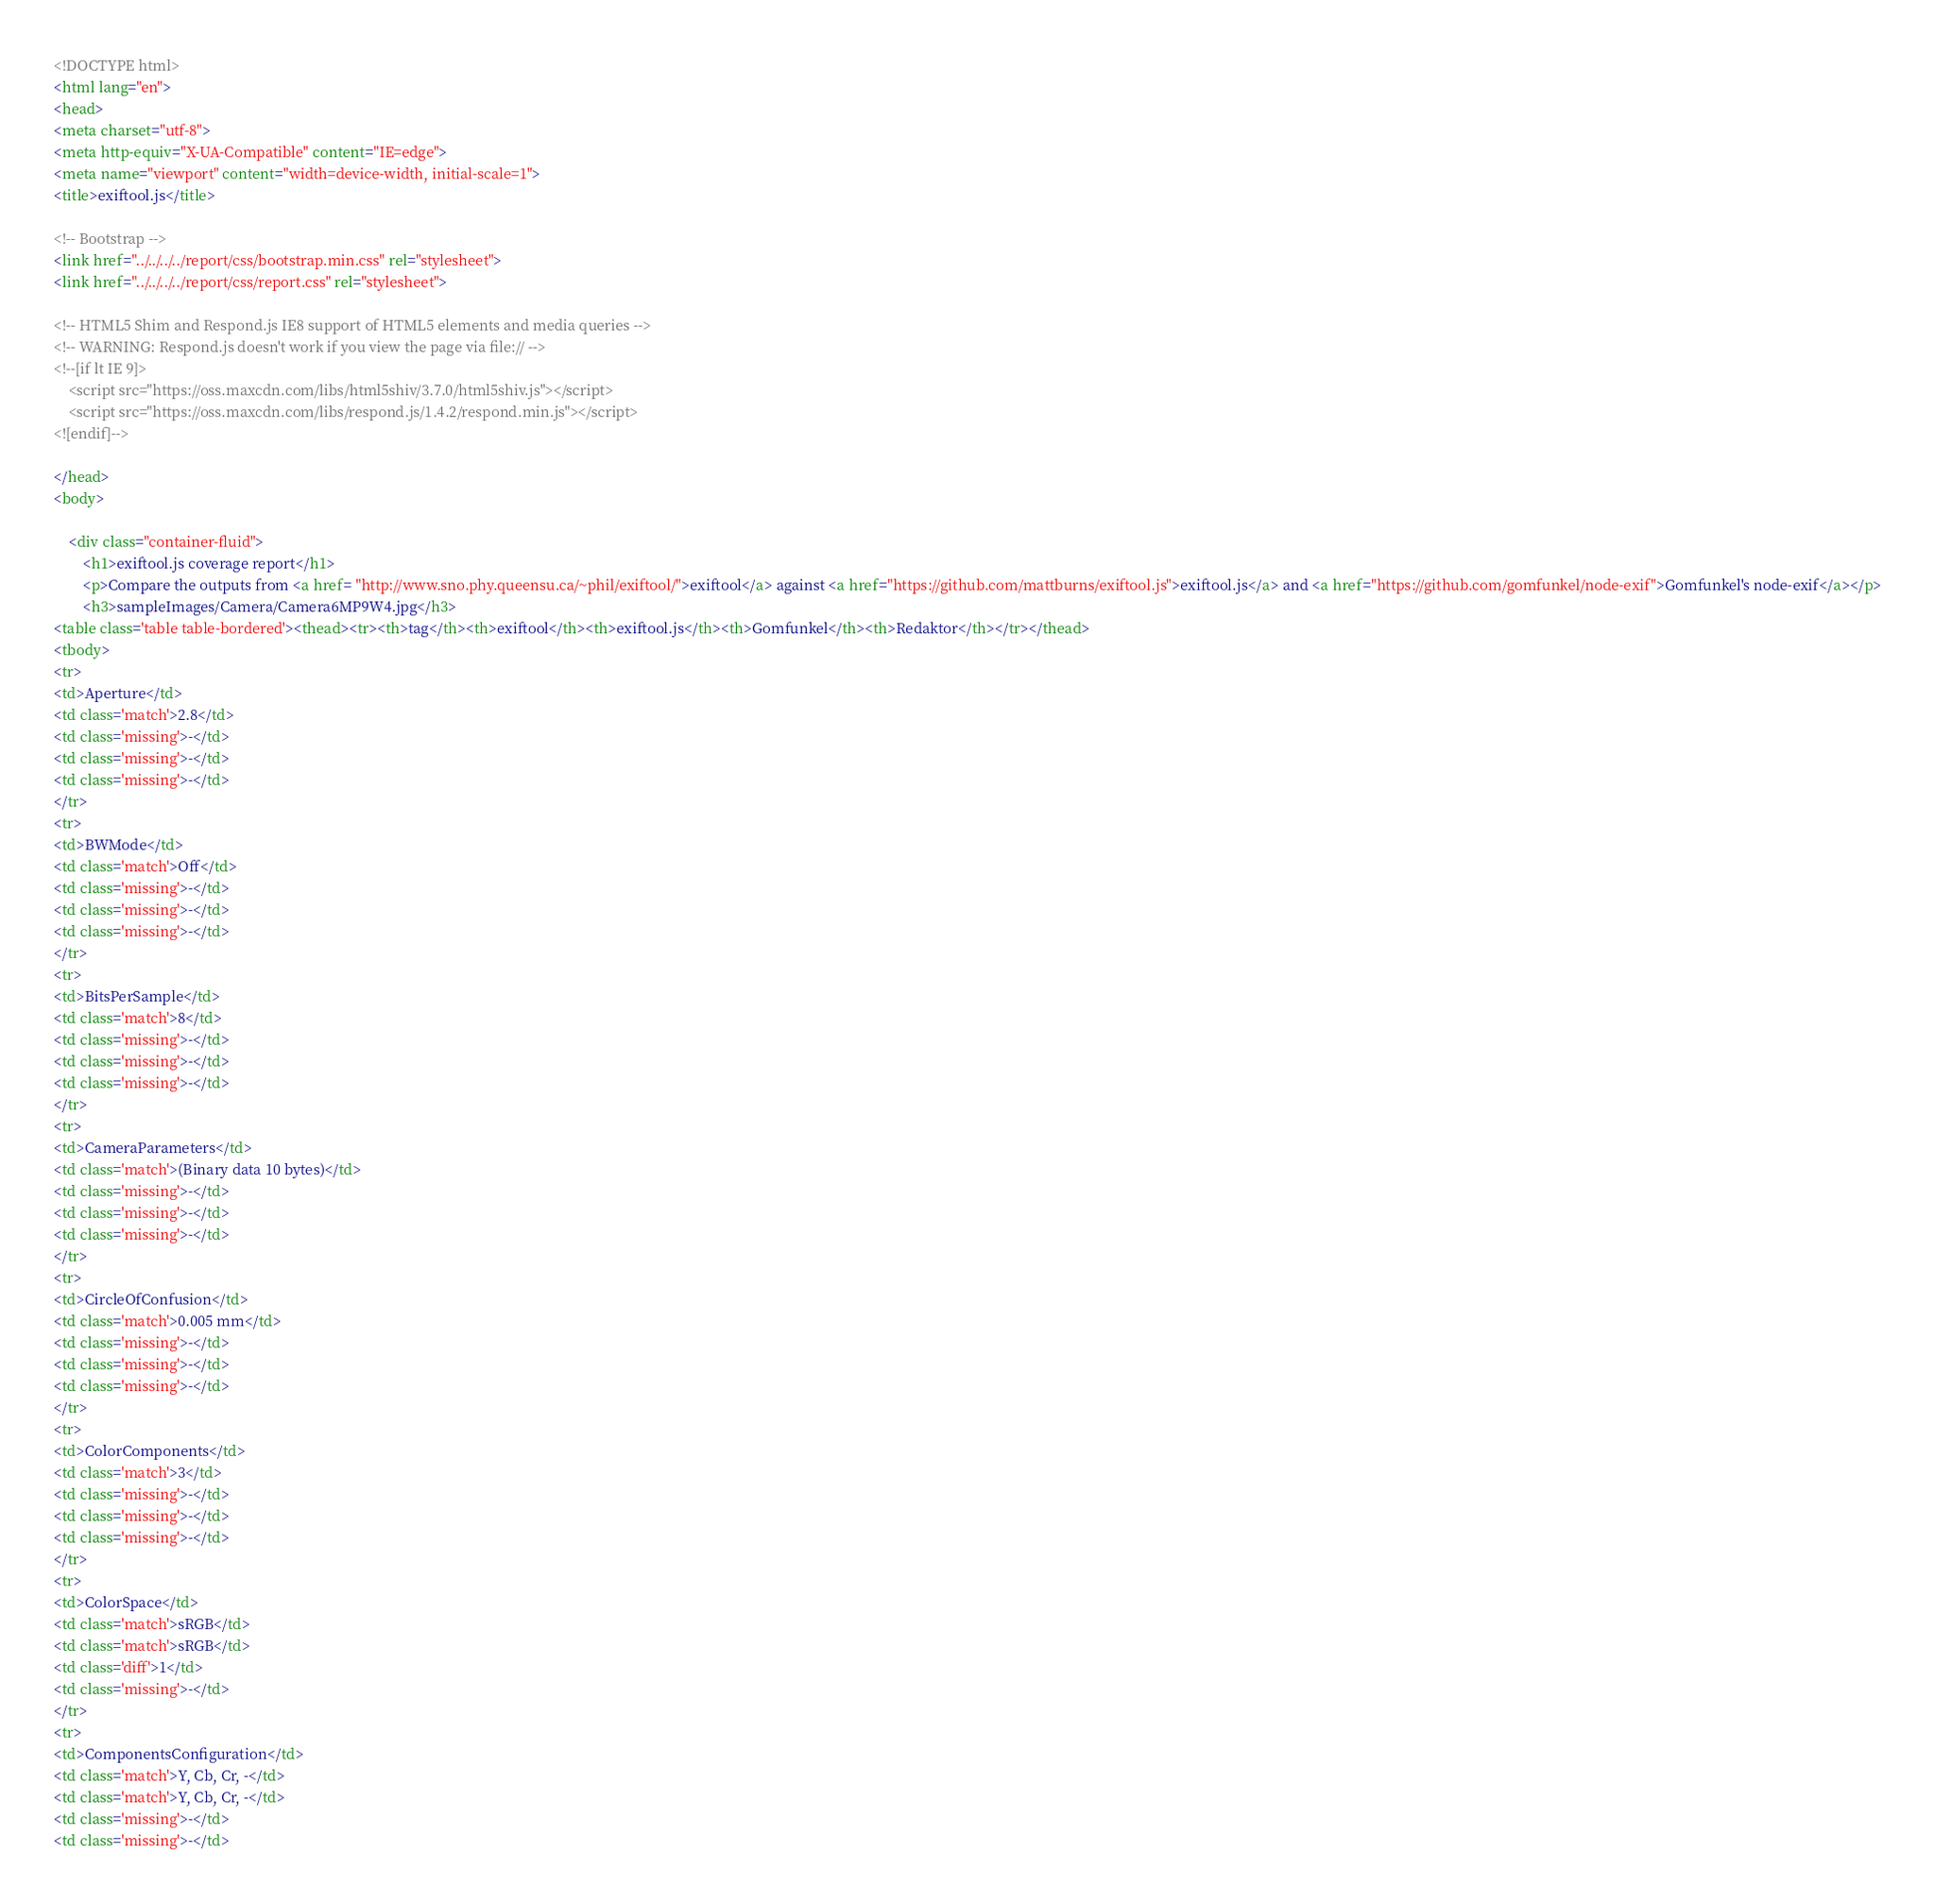<code> <loc_0><loc_0><loc_500><loc_500><_HTML_><!DOCTYPE html>
<html lang="en">
<head>
<meta charset="utf-8">
<meta http-equiv="X-UA-Compatible" content="IE=edge">
<meta name="viewport" content="width=device-width, initial-scale=1">
<title>exiftool.js</title>

<!-- Bootstrap -->
<link href="../../../../report/css/bootstrap.min.css" rel="stylesheet">
<link href="../../../../report/css/report.css" rel="stylesheet">

<!-- HTML5 Shim and Respond.js IE8 support of HTML5 elements and media queries -->
<!-- WARNING: Respond.js doesn't work if you view the page via file:// -->
<!--[if lt IE 9]>
    <script src="https://oss.maxcdn.com/libs/html5shiv/3.7.0/html5shiv.js"></script>
    <script src="https://oss.maxcdn.com/libs/respond.js/1.4.2/respond.min.js"></script>
<![endif]-->

</head>
<body>

    <div class="container-fluid">
        <h1>exiftool.js coverage report</h1>
        <p>Compare the outputs from <a href= "http://www.sno.phy.queensu.ca/~phil/exiftool/">exiftool</a> against <a href="https://github.com/mattburns/exiftool.js">exiftool.js</a> and <a href="https://github.com/gomfunkel/node-exif">Gomfunkel's node-exif</a></p>
        <h3>sampleImages/Camera/Camera6MP9W4.jpg</h3>
<table class='table table-bordered'><thead><tr><th>tag</th><th>exiftool</th><th>exiftool.js</th><th>Gomfunkel</th><th>Redaktor</th></tr></thead>
<tbody>
<tr>
<td>Aperture</td>
<td class='match'>2.8</td>
<td class='missing'>-</td>
<td class='missing'>-</td>
<td class='missing'>-</td>
</tr>
<tr>
<td>BWMode</td>
<td class='match'>Off</td>
<td class='missing'>-</td>
<td class='missing'>-</td>
<td class='missing'>-</td>
</tr>
<tr>
<td>BitsPerSample</td>
<td class='match'>8</td>
<td class='missing'>-</td>
<td class='missing'>-</td>
<td class='missing'>-</td>
</tr>
<tr>
<td>CameraParameters</td>
<td class='match'>(Binary data 10 bytes)</td>
<td class='missing'>-</td>
<td class='missing'>-</td>
<td class='missing'>-</td>
</tr>
<tr>
<td>CircleOfConfusion</td>
<td class='match'>0.005 mm</td>
<td class='missing'>-</td>
<td class='missing'>-</td>
<td class='missing'>-</td>
</tr>
<tr>
<td>ColorComponents</td>
<td class='match'>3</td>
<td class='missing'>-</td>
<td class='missing'>-</td>
<td class='missing'>-</td>
</tr>
<tr>
<td>ColorSpace</td>
<td class='match'>sRGB</td>
<td class='match'>sRGB</td>
<td class='diff'>1</td>
<td class='missing'>-</td>
</tr>
<tr>
<td>ComponentsConfiguration</td>
<td class='match'>Y, Cb, Cr, -</td>
<td class='match'>Y, Cb, Cr, -</td>
<td class='missing'>-</td>
<td class='missing'>-</td></code> 